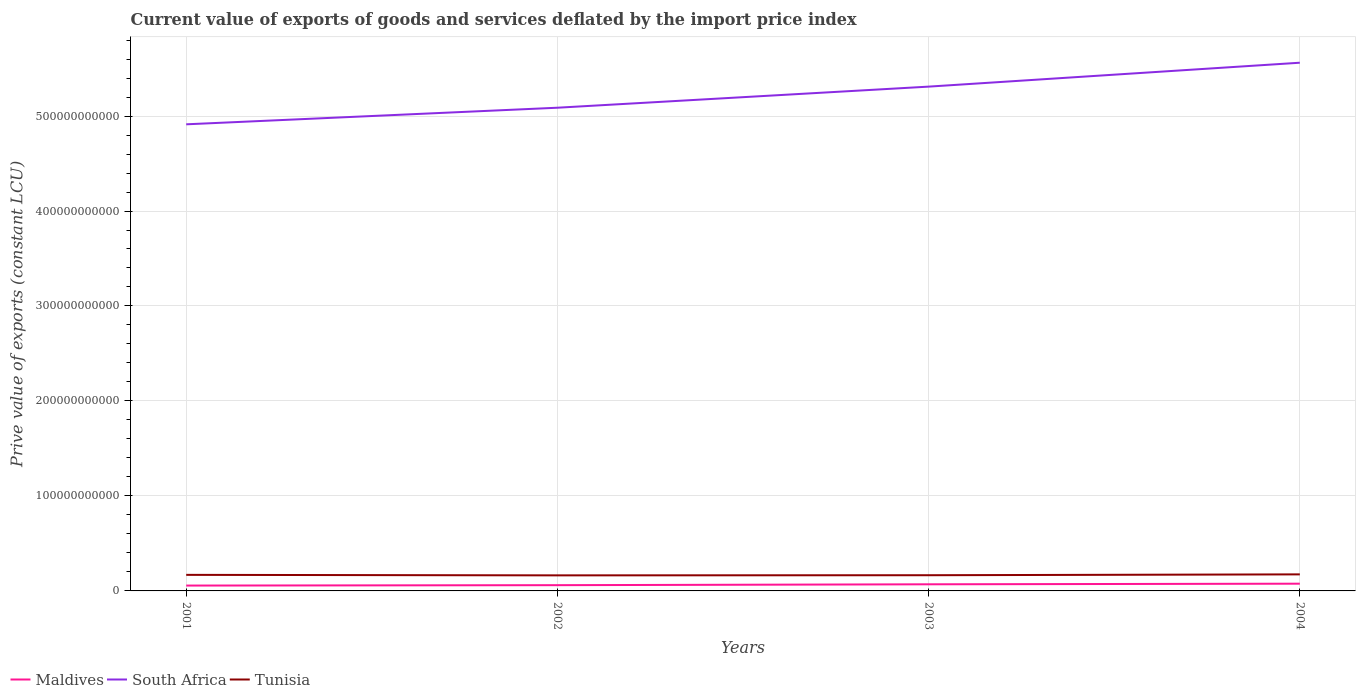How many different coloured lines are there?
Your response must be concise. 3. Does the line corresponding to Tunisia intersect with the line corresponding to South Africa?
Make the answer very short. No. Is the number of lines equal to the number of legend labels?
Provide a short and direct response. Yes. Across all years, what is the maximum prive value of exports in Maldives?
Keep it short and to the point. 5.63e+09. What is the total prive value of exports in Tunisia in the graph?
Your answer should be compact. 5.24e+08. What is the difference between the highest and the second highest prive value of exports in South Africa?
Give a very brief answer. 6.48e+1. How many years are there in the graph?
Keep it short and to the point. 4. What is the difference between two consecutive major ticks on the Y-axis?
Provide a succinct answer. 1.00e+11. How many legend labels are there?
Your answer should be very brief. 3. How are the legend labels stacked?
Make the answer very short. Horizontal. What is the title of the graph?
Give a very brief answer. Current value of exports of goods and services deflated by the import price index. What is the label or title of the X-axis?
Your answer should be very brief. Years. What is the label or title of the Y-axis?
Keep it short and to the point. Prive value of exports (constant LCU). What is the Prive value of exports (constant LCU) in Maldives in 2001?
Offer a terse response. 5.63e+09. What is the Prive value of exports (constant LCU) of South Africa in 2001?
Make the answer very short. 4.91e+11. What is the Prive value of exports (constant LCU) in Tunisia in 2001?
Ensure brevity in your answer.  1.69e+1. What is the Prive value of exports (constant LCU) of Maldives in 2002?
Your answer should be very brief. 6.05e+09. What is the Prive value of exports (constant LCU) of South Africa in 2002?
Provide a succinct answer. 5.09e+11. What is the Prive value of exports (constant LCU) of Tunisia in 2002?
Make the answer very short. 1.64e+1. What is the Prive value of exports (constant LCU) in Maldives in 2003?
Ensure brevity in your answer.  6.97e+09. What is the Prive value of exports (constant LCU) in South Africa in 2003?
Your answer should be compact. 5.31e+11. What is the Prive value of exports (constant LCU) of Tunisia in 2003?
Ensure brevity in your answer.  1.65e+1. What is the Prive value of exports (constant LCU) of Maldives in 2004?
Offer a very short reply. 7.61e+09. What is the Prive value of exports (constant LCU) of South Africa in 2004?
Provide a short and direct response. 5.56e+11. What is the Prive value of exports (constant LCU) of Tunisia in 2004?
Your answer should be very brief. 1.74e+1. Across all years, what is the maximum Prive value of exports (constant LCU) in Maldives?
Provide a succinct answer. 7.61e+09. Across all years, what is the maximum Prive value of exports (constant LCU) of South Africa?
Ensure brevity in your answer.  5.56e+11. Across all years, what is the maximum Prive value of exports (constant LCU) in Tunisia?
Your answer should be very brief. 1.74e+1. Across all years, what is the minimum Prive value of exports (constant LCU) of Maldives?
Ensure brevity in your answer.  5.63e+09. Across all years, what is the minimum Prive value of exports (constant LCU) of South Africa?
Your answer should be very brief. 4.91e+11. Across all years, what is the minimum Prive value of exports (constant LCU) in Tunisia?
Offer a very short reply. 1.64e+1. What is the total Prive value of exports (constant LCU) of Maldives in the graph?
Your answer should be very brief. 2.63e+1. What is the total Prive value of exports (constant LCU) of South Africa in the graph?
Offer a very short reply. 2.09e+12. What is the total Prive value of exports (constant LCU) in Tunisia in the graph?
Offer a terse response. 6.73e+1. What is the difference between the Prive value of exports (constant LCU) of Maldives in 2001 and that in 2002?
Your response must be concise. -4.14e+08. What is the difference between the Prive value of exports (constant LCU) in South Africa in 2001 and that in 2002?
Your response must be concise. -1.75e+1. What is the difference between the Prive value of exports (constant LCU) of Tunisia in 2001 and that in 2002?
Offer a terse response. 5.24e+08. What is the difference between the Prive value of exports (constant LCU) of Maldives in 2001 and that in 2003?
Offer a terse response. -1.33e+09. What is the difference between the Prive value of exports (constant LCU) in South Africa in 2001 and that in 2003?
Make the answer very short. -3.97e+1. What is the difference between the Prive value of exports (constant LCU) in Tunisia in 2001 and that in 2003?
Offer a terse response. 3.87e+08. What is the difference between the Prive value of exports (constant LCU) in Maldives in 2001 and that in 2004?
Ensure brevity in your answer.  -1.98e+09. What is the difference between the Prive value of exports (constant LCU) of South Africa in 2001 and that in 2004?
Make the answer very short. -6.48e+1. What is the difference between the Prive value of exports (constant LCU) in Tunisia in 2001 and that in 2004?
Provide a succinct answer. -5.02e+08. What is the difference between the Prive value of exports (constant LCU) of Maldives in 2002 and that in 2003?
Provide a succinct answer. -9.20e+08. What is the difference between the Prive value of exports (constant LCU) of South Africa in 2002 and that in 2003?
Your answer should be very brief. -2.22e+1. What is the difference between the Prive value of exports (constant LCU) in Tunisia in 2002 and that in 2003?
Give a very brief answer. -1.37e+08. What is the difference between the Prive value of exports (constant LCU) of Maldives in 2002 and that in 2004?
Provide a short and direct response. -1.57e+09. What is the difference between the Prive value of exports (constant LCU) of South Africa in 2002 and that in 2004?
Your response must be concise. -4.74e+1. What is the difference between the Prive value of exports (constant LCU) of Tunisia in 2002 and that in 2004?
Offer a terse response. -1.03e+09. What is the difference between the Prive value of exports (constant LCU) in Maldives in 2003 and that in 2004?
Give a very brief answer. -6.47e+08. What is the difference between the Prive value of exports (constant LCU) in South Africa in 2003 and that in 2004?
Your answer should be very brief. -2.52e+1. What is the difference between the Prive value of exports (constant LCU) in Tunisia in 2003 and that in 2004?
Your answer should be compact. -8.88e+08. What is the difference between the Prive value of exports (constant LCU) of Maldives in 2001 and the Prive value of exports (constant LCU) of South Africa in 2002?
Ensure brevity in your answer.  -5.03e+11. What is the difference between the Prive value of exports (constant LCU) in Maldives in 2001 and the Prive value of exports (constant LCU) in Tunisia in 2002?
Provide a succinct answer. -1.08e+1. What is the difference between the Prive value of exports (constant LCU) in South Africa in 2001 and the Prive value of exports (constant LCU) in Tunisia in 2002?
Ensure brevity in your answer.  4.75e+11. What is the difference between the Prive value of exports (constant LCU) of Maldives in 2001 and the Prive value of exports (constant LCU) of South Africa in 2003?
Provide a short and direct response. -5.25e+11. What is the difference between the Prive value of exports (constant LCU) of Maldives in 2001 and the Prive value of exports (constant LCU) of Tunisia in 2003?
Your answer should be very brief. -1.09e+1. What is the difference between the Prive value of exports (constant LCU) in South Africa in 2001 and the Prive value of exports (constant LCU) in Tunisia in 2003?
Your answer should be compact. 4.75e+11. What is the difference between the Prive value of exports (constant LCU) of Maldives in 2001 and the Prive value of exports (constant LCU) of South Africa in 2004?
Provide a succinct answer. -5.50e+11. What is the difference between the Prive value of exports (constant LCU) in Maldives in 2001 and the Prive value of exports (constant LCU) in Tunisia in 2004?
Your answer should be very brief. -1.18e+1. What is the difference between the Prive value of exports (constant LCU) in South Africa in 2001 and the Prive value of exports (constant LCU) in Tunisia in 2004?
Offer a terse response. 4.74e+11. What is the difference between the Prive value of exports (constant LCU) of Maldives in 2002 and the Prive value of exports (constant LCU) of South Africa in 2003?
Provide a short and direct response. -5.25e+11. What is the difference between the Prive value of exports (constant LCU) of Maldives in 2002 and the Prive value of exports (constant LCU) of Tunisia in 2003?
Your response must be concise. -1.05e+1. What is the difference between the Prive value of exports (constant LCU) in South Africa in 2002 and the Prive value of exports (constant LCU) in Tunisia in 2003?
Your answer should be very brief. 4.92e+11. What is the difference between the Prive value of exports (constant LCU) in Maldives in 2002 and the Prive value of exports (constant LCU) in South Africa in 2004?
Your answer should be compact. -5.50e+11. What is the difference between the Prive value of exports (constant LCU) of Maldives in 2002 and the Prive value of exports (constant LCU) of Tunisia in 2004?
Give a very brief answer. -1.14e+1. What is the difference between the Prive value of exports (constant LCU) of South Africa in 2002 and the Prive value of exports (constant LCU) of Tunisia in 2004?
Keep it short and to the point. 4.91e+11. What is the difference between the Prive value of exports (constant LCU) of Maldives in 2003 and the Prive value of exports (constant LCU) of South Africa in 2004?
Make the answer very short. -5.49e+11. What is the difference between the Prive value of exports (constant LCU) of Maldives in 2003 and the Prive value of exports (constant LCU) of Tunisia in 2004?
Ensure brevity in your answer.  -1.04e+1. What is the difference between the Prive value of exports (constant LCU) of South Africa in 2003 and the Prive value of exports (constant LCU) of Tunisia in 2004?
Offer a terse response. 5.14e+11. What is the average Prive value of exports (constant LCU) of Maldives per year?
Your answer should be compact. 6.57e+09. What is the average Prive value of exports (constant LCU) in South Africa per year?
Give a very brief answer. 5.22e+11. What is the average Prive value of exports (constant LCU) of Tunisia per year?
Ensure brevity in your answer.  1.68e+1. In the year 2001, what is the difference between the Prive value of exports (constant LCU) in Maldives and Prive value of exports (constant LCU) in South Africa?
Offer a very short reply. -4.86e+11. In the year 2001, what is the difference between the Prive value of exports (constant LCU) of Maldives and Prive value of exports (constant LCU) of Tunisia?
Ensure brevity in your answer.  -1.13e+1. In the year 2001, what is the difference between the Prive value of exports (constant LCU) of South Africa and Prive value of exports (constant LCU) of Tunisia?
Your response must be concise. 4.74e+11. In the year 2002, what is the difference between the Prive value of exports (constant LCU) in Maldives and Prive value of exports (constant LCU) in South Africa?
Your answer should be very brief. -5.03e+11. In the year 2002, what is the difference between the Prive value of exports (constant LCU) in Maldives and Prive value of exports (constant LCU) in Tunisia?
Keep it short and to the point. -1.03e+1. In the year 2002, what is the difference between the Prive value of exports (constant LCU) in South Africa and Prive value of exports (constant LCU) in Tunisia?
Make the answer very short. 4.92e+11. In the year 2003, what is the difference between the Prive value of exports (constant LCU) of Maldives and Prive value of exports (constant LCU) of South Africa?
Provide a short and direct response. -5.24e+11. In the year 2003, what is the difference between the Prive value of exports (constant LCU) of Maldives and Prive value of exports (constant LCU) of Tunisia?
Your response must be concise. -9.56e+09. In the year 2003, what is the difference between the Prive value of exports (constant LCU) of South Africa and Prive value of exports (constant LCU) of Tunisia?
Offer a terse response. 5.14e+11. In the year 2004, what is the difference between the Prive value of exports (constant LCU) in Maldives and Prive value of exports (constant LCU) in South Africa?
Make the answer very short. -5.49e+11. In the year 2004, what is the difference between the Prive value of exports (constant LCU) of Maldives and Prive value of exports (constant LCU) of Tunisia?
Your answer should be very brief. -9.80e+09. In the year 2004, what is the difference between the Prive value of exports (constant LCU) in South Africa and Prive value of exports (constant LCU) in Tunisia?
Ensure brevity in your answer.  5.39e+11. What is the ratio of the Prive value of exports (constant LCU) in Maldives in 2001 to that in 2002?
Provide a succinct answer. 0.93. What is the ratio of the Prive value of exports (constant LCU) of South Africa in 2001 to that in 2002?
Make the answer very short. 0.97. What is the ratio of the Prive value of exports (constant LCU) of Tunisia in 2001 to that in 2002?
Ensure brevity in your answer.  1.03. What is the ratio of the Prive value of exports (constant LCU) in Maldives in 2001 to that in 2003?
Give a very brief answer. 0.81. What is the ratio of the Prive value of exports (constant LCU) of South Africa in 2001 to that in 2003?
Offer a very short reply. 0.93. What is the ratio of the Prive value of exports (constant LCU) in Tunisia in 2001 to that in 2003?
Make the answer very short. 1.02. What is the ratio of the Prive value of exports (constant LCU) in Maldives in 2001 to that in 2004?
Keep it short and to the point. 0.74. What is the ratio of the Prive value of exports (constant LCU) in South Africa in 2001 to that in 2004?
Your answer should be very brief. 0.88. What is the ratio of the Prive value of exports (constant LCU) in Tunisia in 2001 to that in 2004?
Make the answer very short. 0.97. What is the ratio of the Prive value of exports (constant LCU) of Maldives in 2002 to that in 2003?
Provide a short and direct response. 0.87. What is the ratio of the Prive value of exports (constant LCU) of South Africa in 2002 to that in 2003?
Provide a succinct answer. 0.96. What is the ratio of the Prive value of exports (constant LCU) in Tunisia in 2002 to that in 2003?
Your answer should be very brief. 0.99. What is the ratio of the Prive value of exports (constant LCU) of Maldives in 2002 to that in 2004?
Your answer should be very brief. 0.79. What is the ratio of the Prive value of exports (constant LCU) of South Africa in 2002 to that in 2004?
Your answer should be very brief. 0.91. What is the ratio of the Prive value of exports (constant LCU) in Tunisia in 2002 to that in 2004?
Keep it short and to the point. 0.94. What is the ratio of the Prive value of exports (constant LCU) in Maldives in 2003 to that in 2004?
Give a very brief answer. 0.92. What is the ratio of the Prive value of exports (constant LCU) of South Africa in 2003 to that in 2004?
Your answer should be compact. 0.95. What is the ratio of the Prive value of exports (constant LCU) of Tunisia in 2003 to that in 2004?
Your answer should be very brief. 0.95. What is the difference between the highest and the second highest Prive value of exports (constant LCU) in Maldives?
Offer a very short reply. 6.47e+08. What is the difference between the highest and the second highest Prive value of exports (constant LCU) of South Africa?
Your response must be concise. 2.52e+1. What is the difference between the highest and the second highest Prive value of exports (constant LCU) of Tunisia?
Provide a succinct answer. 5.02e+08. What is the difference between the highest and the lowest Prive value of exports (constant LCU) in Maldives?
Give a very brief answer. 1.98e+09. What is the difference between the highest and the lowest Prive value of exports (constant LCU) of South Africa?
Provide a succinct answer. 6.48e+1. What is the difference between the highest and the lowest Prive value of exports (constant LCU) in Tunisia?
Keep it short and to the point. 1.03e+09. 